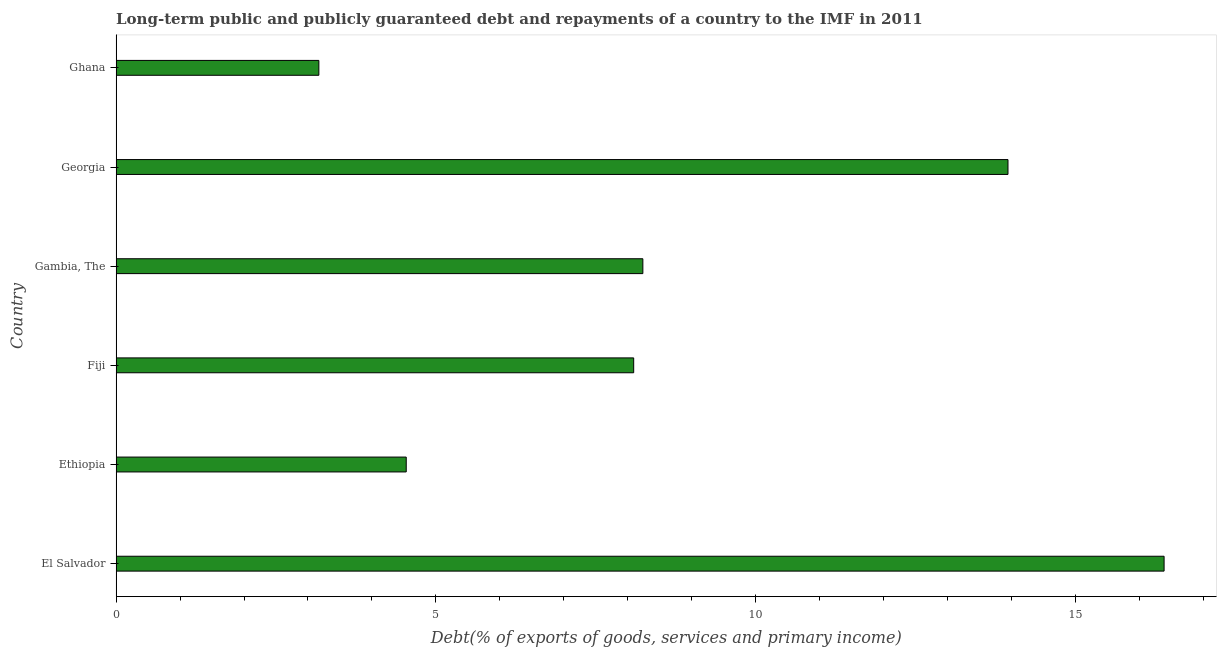Does the graph contain any zero values?
Keep it short and to the point. No. Does the graph contain grids?
Make the answer very short. No. What is the title of the graph?
Provide a short and direct response. Long-term public and publicly guaranteed debt and repayments of a country to the IMF in 2011. What is the label or title of the X-axis?
Ensure brevity in your answer.  Debt(% of exports of goods, services and primary income). What is the label or title of the Y-axis?
Ensure brevity in your answer.  Country. What is the debt service in Gambia, The?
Provide a succinct answer. 8.24. Across all countries, what is the maximum debt service?
Make the answer very short. 16.39. Across all countries, what is the minimum debt service?
Make the answer very short. 3.17. In which country was the debt service maximum?
Provide a succinct answer. El Salvador. What is the sum of the debt service?
Offer a very short reply. 54.37. What is the difference between the debt service in Ethiopia and Ghana?
Offer a very short reply. 1.37. What is the average debt service per country?
Keep it short and to the point. 9.06. What is the median debt service?
Provide a short and direct response. 8.16. In how many countries, is the debt service greater than 5 %?
Make the answer very short. 4. What is the ratio of the debt service in Gambia, The to that in Georgia?
Ensure brevity in your answer.  0.59. Is the debt service in El Salvador less than that in Ethiopia?
Your answer should be compact. No. Is the difference between the debt service in Ethiopia and Fiji greater than the difference between any two countries?
Offer a very short reply. No. What is the difference between the highest and the second highest debt service?
Your answer should be compact. 2.44. Is the sum of the debt service in Ethiopia and Fiji greater than the maximum debt service across all countries?
Offer a very short reply. No. What is the difference between the highest and the lowest debt service?
Your response must be concise. 13.22. In how many countries, is the debt service greater than the average debt service taken over all countries?
Keep it short and to the point. 2. How many bars are there?
Make the answer very short. 6. Are all the bars in the graph horizontal?
Provide a short and direct response. Yes. How many countries are there in the graph?
Your answer should be compact. 6. What is the difference between two consecutive major ticks on the X-axis?
Provide a succinct answer. 5. Are the values on the major ticks of X-axis written in scientific E-notation?
Provide a short and direct response. No. What is the Debt(% of exports of goods, services and primary income) in El Salvador?
Offer a terse response. 16.39. What is the Debt(% of exports of goods, services and primary income) of Ethiopia?
Provide a short and direct response. 4.54. What is the Debt(% of exports of goods, services and primary income) in Fiji?
Keep it short and to the point. 8.09. What is the Debt(% of exports of goods, services and primary income) in Gambia, The?
Offer a terse response. 8.24. What is the Debt(% of exports of goods, services and primary income) in Georgia?
Your response must be concise. 13.95. What is the Debt(% of exports of goods, services and primary income) of Ghana?
Your answer should be compact. 3.17. What is the difference between the Debt(% of exports of goods, services and primary income) in El Salvador and Ethiopia?
Provide a short and direct response. 11.85. What is the difference between the Debt(% of exports of goods, services and primary income) in El Salvador and Fiji?
Provide a succinct answer. 8.29. What is the difference between the Debt(% of exports of goods, services and primary income) in El Salvador and Gambia, The?
Make the answer very short. 8.15. What is the difference between the Debt(% of exports of goods, services and primary income) in El Salvador and Georgia?
Your response must be concise. 2.44. What is the difference between the Debt(% of exports of goods, services and primary income) in El Salvador and Ghana?
Ensure brevity in your answer.  13.22. What is the difference between the Debt(% of exports of goods, services and primary income) in Ethiopia and Fiji?
Offer a very short reply. -3.56. What is the difference between the Debt(% of exports of goods, services and primary income) in Ethiopia and Gambia, The?
Provide a short and direct response. -3.7. What is the difference between the Debt(% of exports of goods, services and primary income) in Ethiopia and Georgia?
Provide a short and direct response. -9.41. What is the difference between the Debt(% of exports of goods, services and primary income) in Ethiopia and Ghana?
Give a very brief answer. 1.37. What is the difference between the Debt(% of exports of goods, services and primary income) in Fiji and Gambia, The?
Keep it short and to the point. -0.14. What is the difference between the Debt(% of exports of goods, services and primary income) in Fiji and Georgia?
Your answer should be compact. -5.85. What is the difference between the Debt(% of exports of goods, services and primary income) in Fiji and Ghana?
Keep it short and to the point. 4.92. What is the difference between the Debt(% of exports of goods, services and primary income) in Gambia, The and Georgia?
Give a very brief answer. -5.71. What is the difference between the Debt(% of exports of goods, services and primary income) in Gambia, The and Ghana?
Provide a short and direct response. 5.07. What is the difference between the Debt(% of exports of goods, services and primary income) in Georgia and Ghana?
Keep it short and to the point. 10.78. What is the ratio of the Debt(% of exports of goods, services and primary income) in El Salvador to that in Ethiopia?
Your response must be concise. 3.61. What is the ratio of the Debt(% of exports of goods, services and primary income) in El Salvador to that in Fiji?
Your answer should be compact. 2.02. What is the ratio of the Debt(% of exports of goods, services and primary income) in El Salvador to that in Gambia, The?
Give a very brief answer. 1.99. What is the ratio of the Debt(% of exports of goods, services and primary income) in El Salvador to that in Georgia?
Your answer should be very brief. 1.18. What is the ratio of the Debt(% of exports of goods, services and primary income) in El Salvador to that in Ghana?
Your response must be concise. 5.17. What is the ratio of the Debt(% of exports of goods, services and primary income) in Ethiopia to that in Fiji?
Offer a terse response. 0.56. What is the ratio of the Debt(% of exports of goods, services and primary income) in Ethiopia to that in Gambia, The?
Your answer should be compact. 0.55. What is the ratio of the Debt(% of exports of goods, services and primary income) in Ethiopia to that in Georgia?
Your answer should be very brief. 0.33. What is the ratio of the Debt(% of exports of goods, services and primary income) in Ethiopia to that in Ghana?
Ensure brevity in your answer.  1.43. What is the ratio of the Debt(% of exports of goods, services and primary income) in Fiji to that in Gambia, The?
Your response must be concise. 0.98. What is the ratio of the Debt(% of exports of goods, services and primary income) in Fiji to that in Georgia?
Offer a very short reply. 0.58. What is the ratio of the Debt(% of exports of goods, services and primary income) in Fiji to that in Ghana?
Provide a short and direct response. 2.55. What is the ratio of the Debt(% of exports of goods, services and primary income) in Gambia, The to that in Georgia?
Give a very brief answer. 0.59. What is the ratio of the Debt(% of exports of goods, services and primary income) in Gambia, The to that in Ghana?
Give a very brief answer. 2.6. What is the ratio of the Debt(% of exports of goods, services and primary income) in Georgia to that in Ghana?
Give a very brief answer. 4.4. 